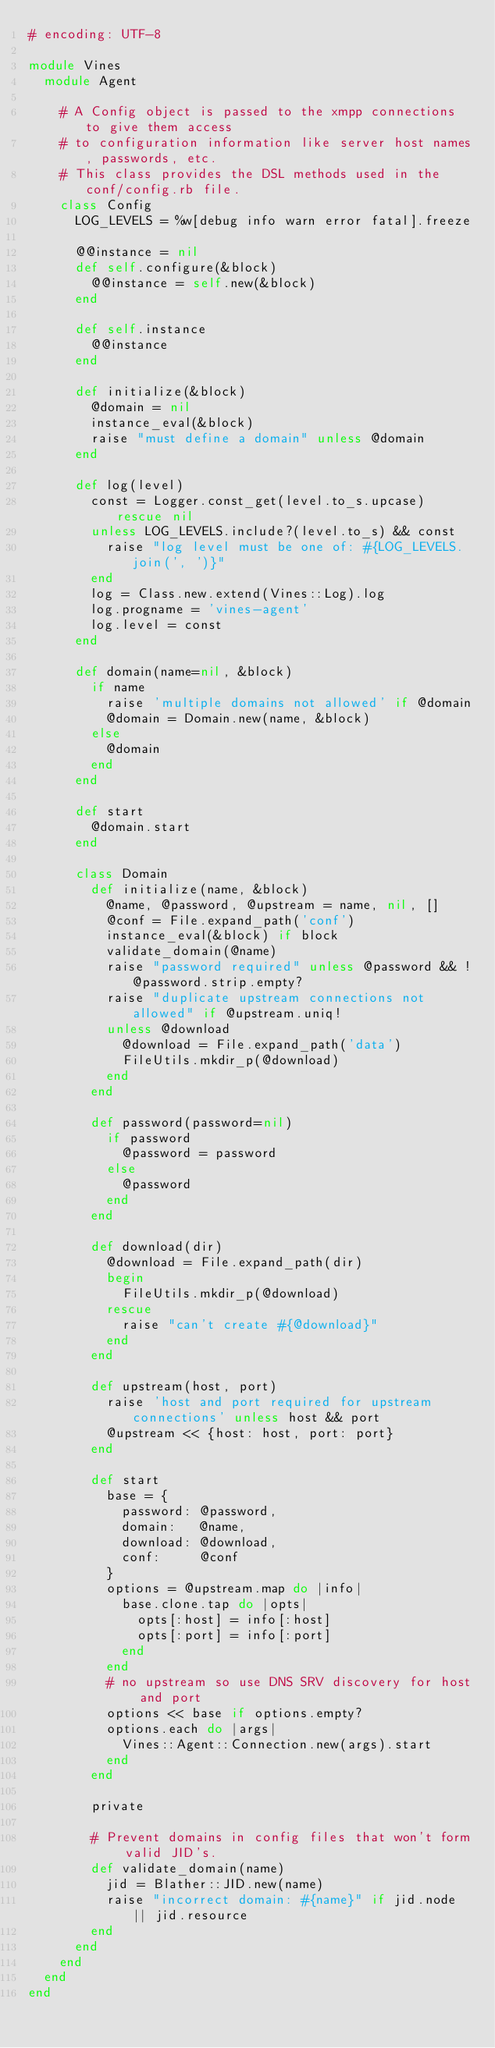Convert code to text. <code><loc_0><loc_0><loc_500><loc_500><_Ruby_># encoding: UTF-8

module Vines
  module Agent

    # A Config object is passed to the xmpp connections to give them access
    # to configuration information like server host names, passwords, etc.
    # This class provides the DSL methods used in the conf/config.rb file.
    class Config
      LOG_LEVELS = %w[debug info warn error fatal].freeze

      @@instance = nil
      def self.configure(&block)
        @@instance = self.new(&block)
      end

      def self.instance
        @@instance
      end

      def initialize(&block)
        @domain = nil
        instance_eval(&block)
        raise "must define a domain" unless @domain
      end

      def log(level)
        const = Logger.const_get(level.to_s.upcase) rescue nil
        unless LOG_LEVELS.include?(level.to_s) && const
          raise "log level must be one of: #{LOG_LEVELS.join(', ')}"
        end
        log = Class.new.extend(Vines::Log).log
        log.progname = 'vines-agent'
        log.level = const
      end

      def domain(name=nil, &block)
        if name
          raise 'multiple domains not allowed' if @domain
          @domain = Domain.new(name, &block)
        else
          @domain
        end
      end

      def start
        @domain.start
      end

      class Domain
        def initialize(name, &block)
          @name, @password, @upstream = name, nil, []
          @conf = File.expand_path('conf')
          instance_eval(&block) if block
          validate_domain(@name)
          raise "password required" unless @password && !@password.strip.empty?
          raise "duplicate upstream connections not allowed" if @upstream.uniq!
          unless @download
            @download = File.expand_path('data')
            FileUtils.mkdir_p(@download)
          end
        end

        def password(password=nil)
          if password
            @password = password
          else
            @password
          end
        end

        def download(dir)
          @download = File.expand_path(dir)
          begin
            FileUtils.mkdir_p(@download)
          rescue
            raise "can't create #{@download}"
          end
        end

        def upstream(host, port)
          raise 'host and port required for upstream connections' unless host && port
          @upstream << {host: host, port: port}
        end

        def start
          base = {
            password: @password,
            domain:   @name,
            download: @download,
            conf:     @conf
          }
          options = @upstream.map do |info|
            base.clone.tap do |opts|
              opts[:host] = info[:host]
              opts[:port] = info[:port]
            end
          end
          # no upstream so use DNS SRV discovery for host and port
          options << base if options.empty?
          options.each do |args|
            Vines::Agent::Connection.new(args).start
          end
        end

        private

        # Prevent domains in config files that won't form valid JID's.
        def validate_domain(name)
          jid = Blather::JID.new(name)
          raise "incorrect domain: #{name}" if jid.node || jid.resource
        end
      end
    end
  end
end</code> 